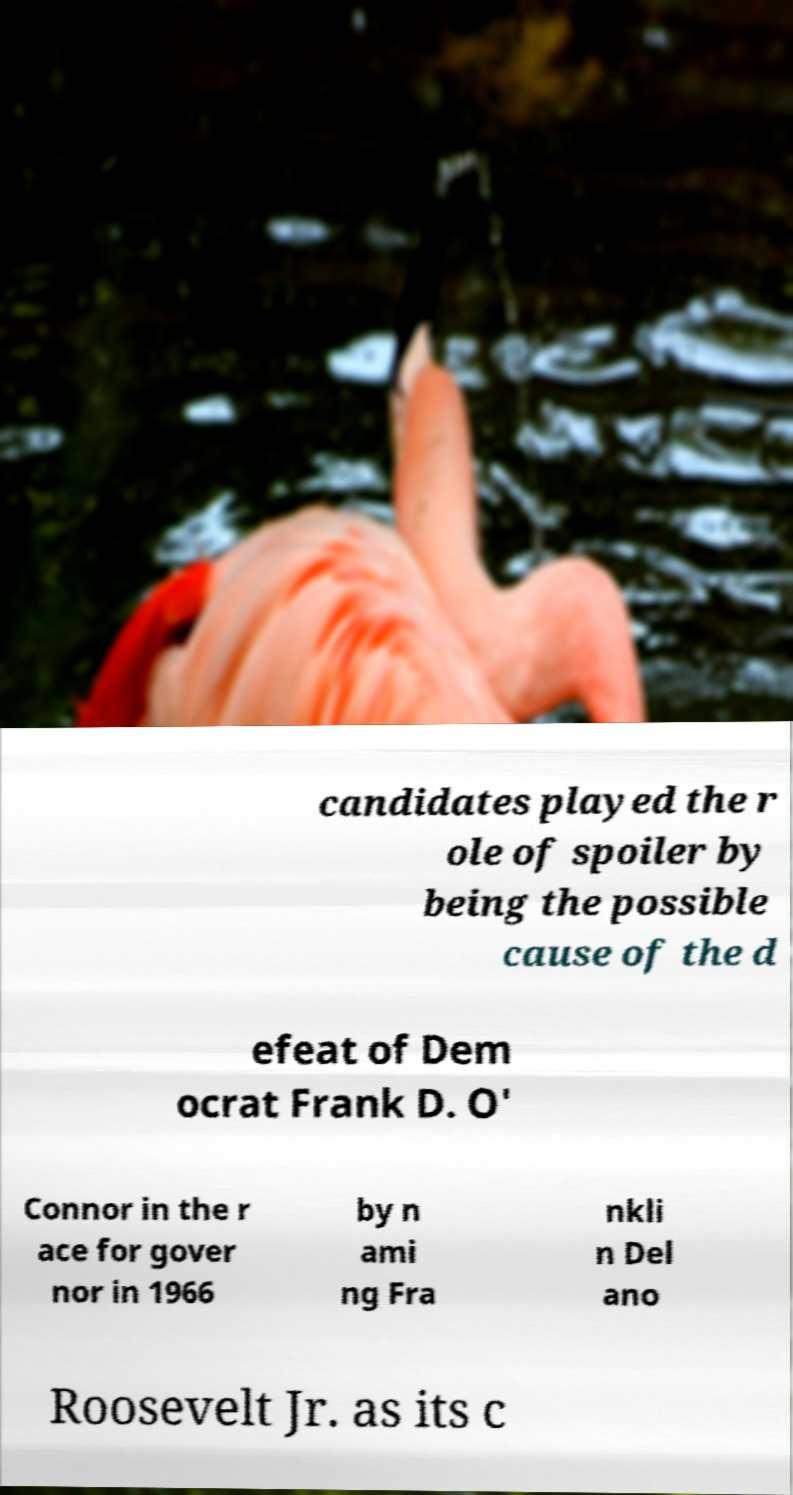Please read and relay the text visible in this image. What does it say? candidates played the r ole of spoiler by being the possible cause of the d efeat of Dem ocrat Frank D. O' Connor in the r ace for gover nor in 1966 by n ami ng Fra nkli n Del ano Roosevelt Jr. as its c 